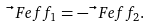Convert formula to latex. <formula><loc_0><loc_0><loc_500><loc_500>\vec { \ } F e f f _ { 1 } = - \vec { \ } F e f f _ { 2 } .</formula> 